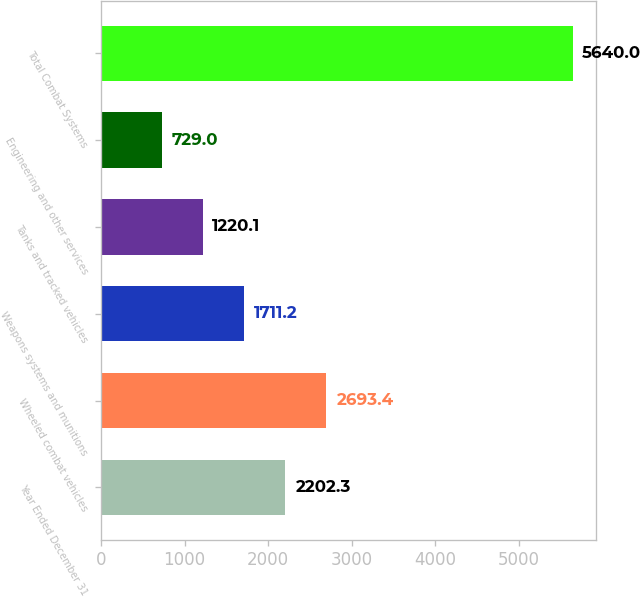Convert chart. <chart><loc_0><loc_0><loc_500><loc_500><bar_chart><fcel>Year Ended December 31<fcel>Wheeled combat vehicles<fcel>Weapons systems and munitions<fcel>Tanks and tracked vehicles<fcel>Engineering and other services<fcel>Total Combat Systems<nl><fcel>2202.3<fcel>2693.4<fcel>1711.2<fcel>1220.1<fcel>729<fcel>5640<nl></chart> 